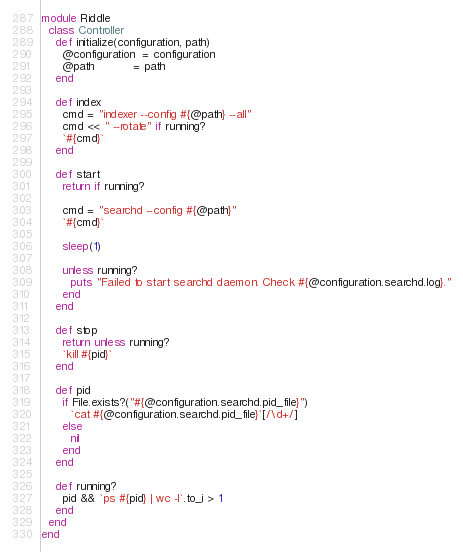Convert code to text. <code><loc_0><loc_0><loc_500><loc_500><_Ruby_>module Riddle
  class Controller
    def initialize(configuration, path)
      @configuration  = configuration
      @path           = path
    end
    
    def index
      cmd = "indexer --config #{@path} --all"
      cmd << " --rotate" if running?
      `#{cmd}`
    end

    def start
      return if running?

      cmd = "searchd --config #{@path}"
      `#{cmd}`    

      sleep(1)

      unless running?
        puts "Failed to start searchd daemon. Check #{@configuration.searchd.log}."
      end
    end

    def stop
      return unless running?
      `kill #{pid}`
    end

    def pid
      if File.exists?("#{@configuration.searchd.pid_file}")
        `cat #{@configuration.searchd.pid_file}`[/\d+/]
      else
        nil
      end
    end

    def running?
      pid && `ps #{pid} | wc -l`.to_i > 1
    end
  end
end</code> 